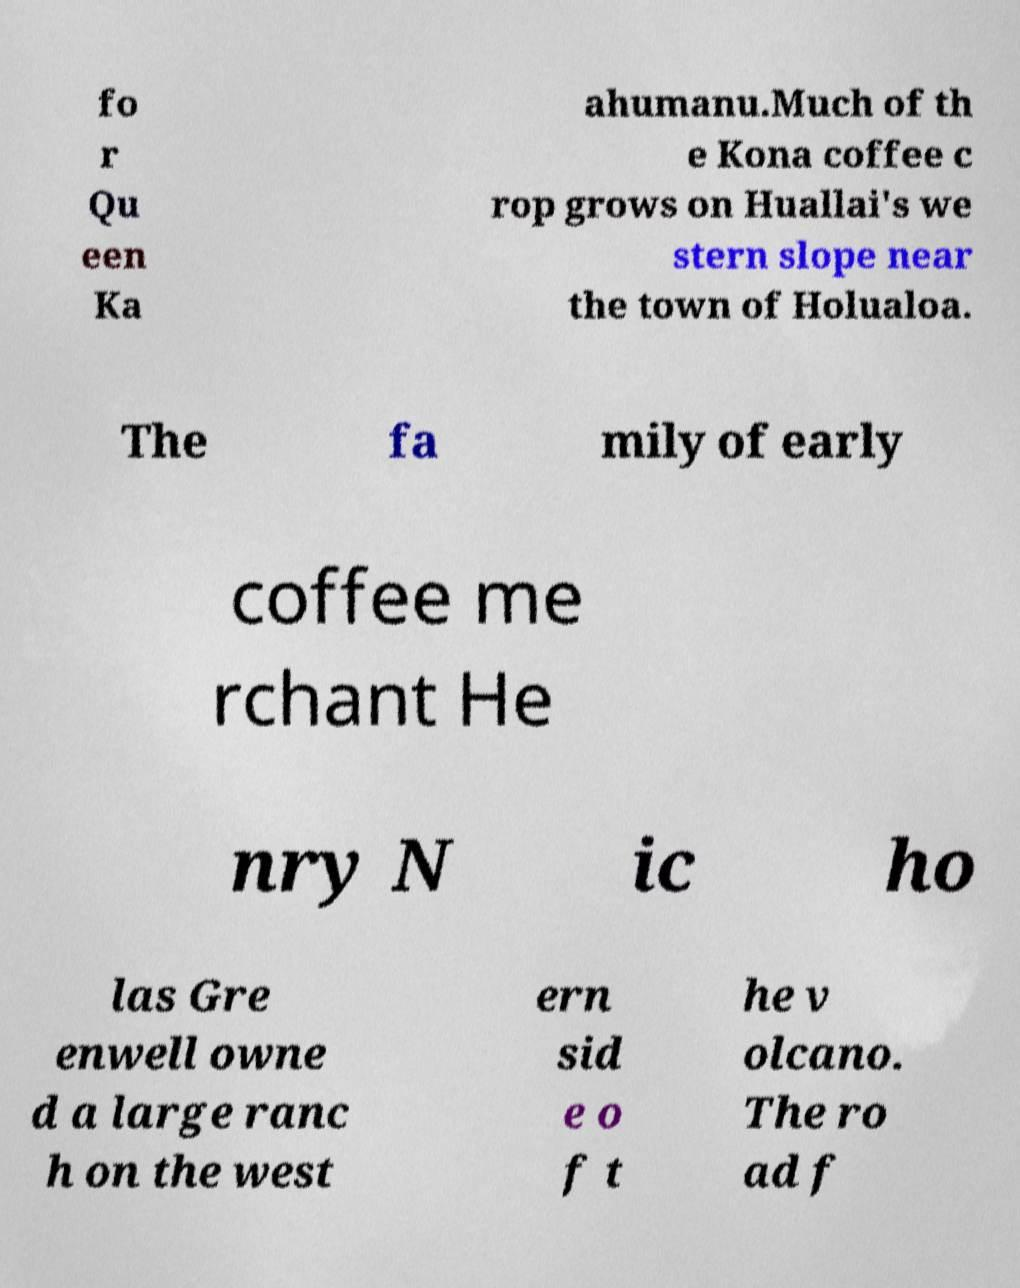There's text embedded in this image that I need extracted. Can you transcribe it verbatim? fo r Qu een Ka ahumanu.Much of th e Kona coffee c rop grows on Huallai's we stern slope near the town of Holualoa. The fa mily of early coffee me rchant He nry N ic ho las Gre enwell owne d a large ranc h on the west ern sid e o f t he v olcano. The ro ad f 